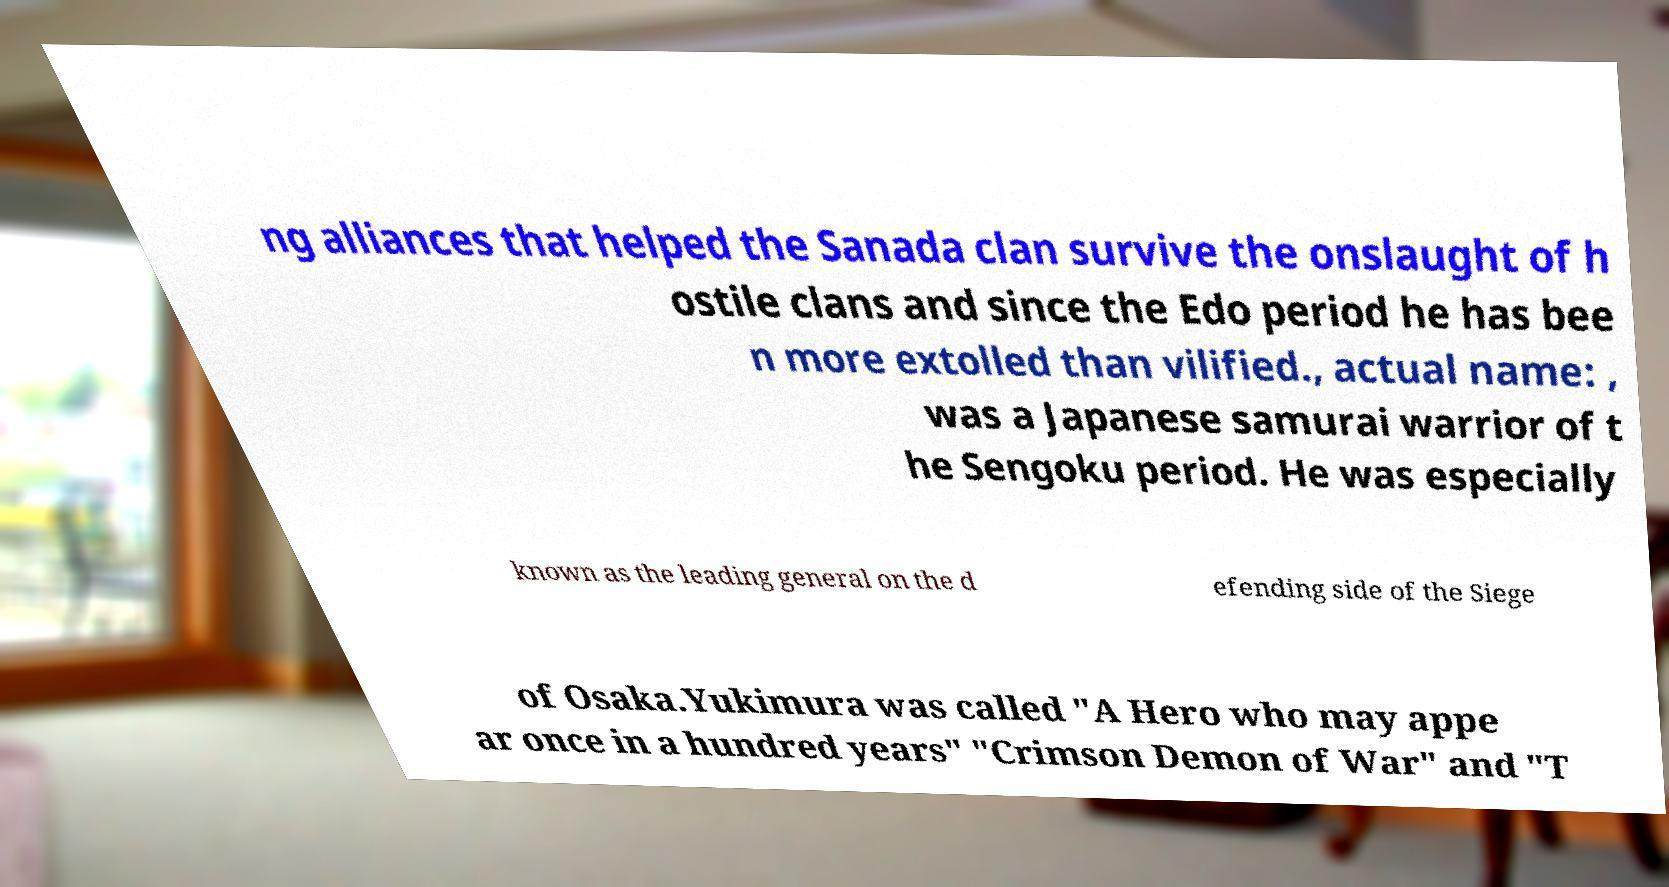For documentation purposes, I need the text within this image transcribed. Could you provide that? ng alliances that helped the Sanada clan survive the onslaught of h ostile clans and since the Edo period he has bee n more extolled than vilified., actual name: , was a Japanese samurai warrior of t he Sengoku period. He was especially known as the leading general on the d efending side of the Siege of Osaka.Yukimura was called "A Hero who may appe ar once in a hundred years" "Crimson Demon of War" and "T 